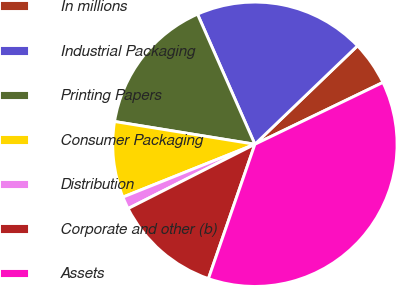Convert chart to OTSL. <chart><loc_0><loc_0><loc_500><loc_500><pie_chart><fcel>In millions<fcel>Industrial Packaging<fcel>Printing Papers<fcel>Consumer Packaging<fcel>Distribution<fcel>Corporate and other (b)<fcel>Assets<nl><fcel>5.01%<fcel>19.44%<fcel>15.83%<fcel>8.62%<fcel>1.41%<fcel>12.23%<fcel>37.46%<nl></chart> 